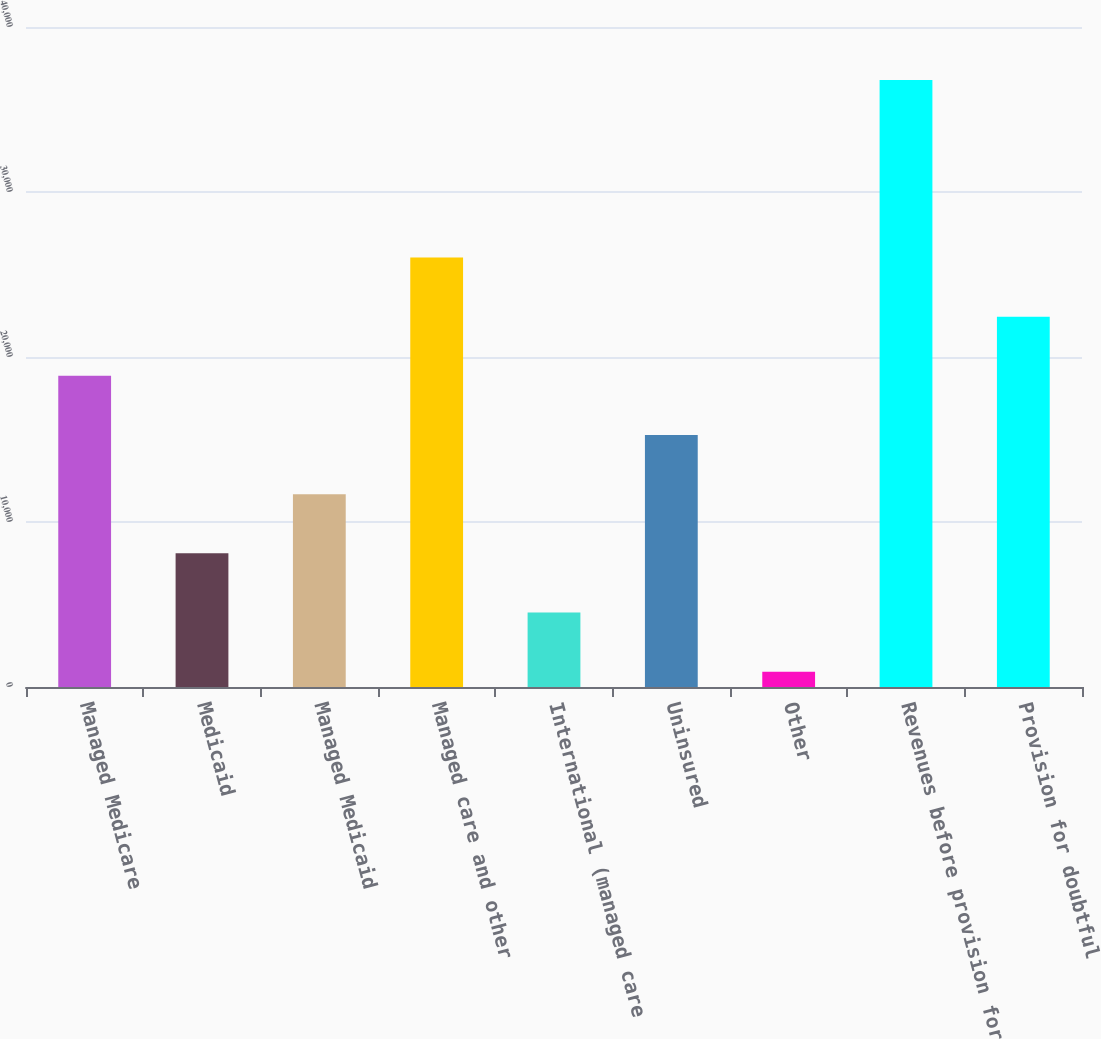Convert chart. <chart><loc_0><loc_0><loc_500><loc_500><bar_chart><fcel>Managed Medicare<fcel>Medicaid<fcel>Managed Medicaid<fcel>Managed care and other<fcel>International (managed care<fcel>Uninsured<fcel>Other<fcel>Revenues before provision for<fcel>Provision for doubtful<nl><fcel>18857<fcel>8101.4<fcel>11686.6<fcel>26027.4<fcel>4516.2<fcel>15271.8<fcel>931<fcel>36783<fcel>22442.2<nl></chart> 